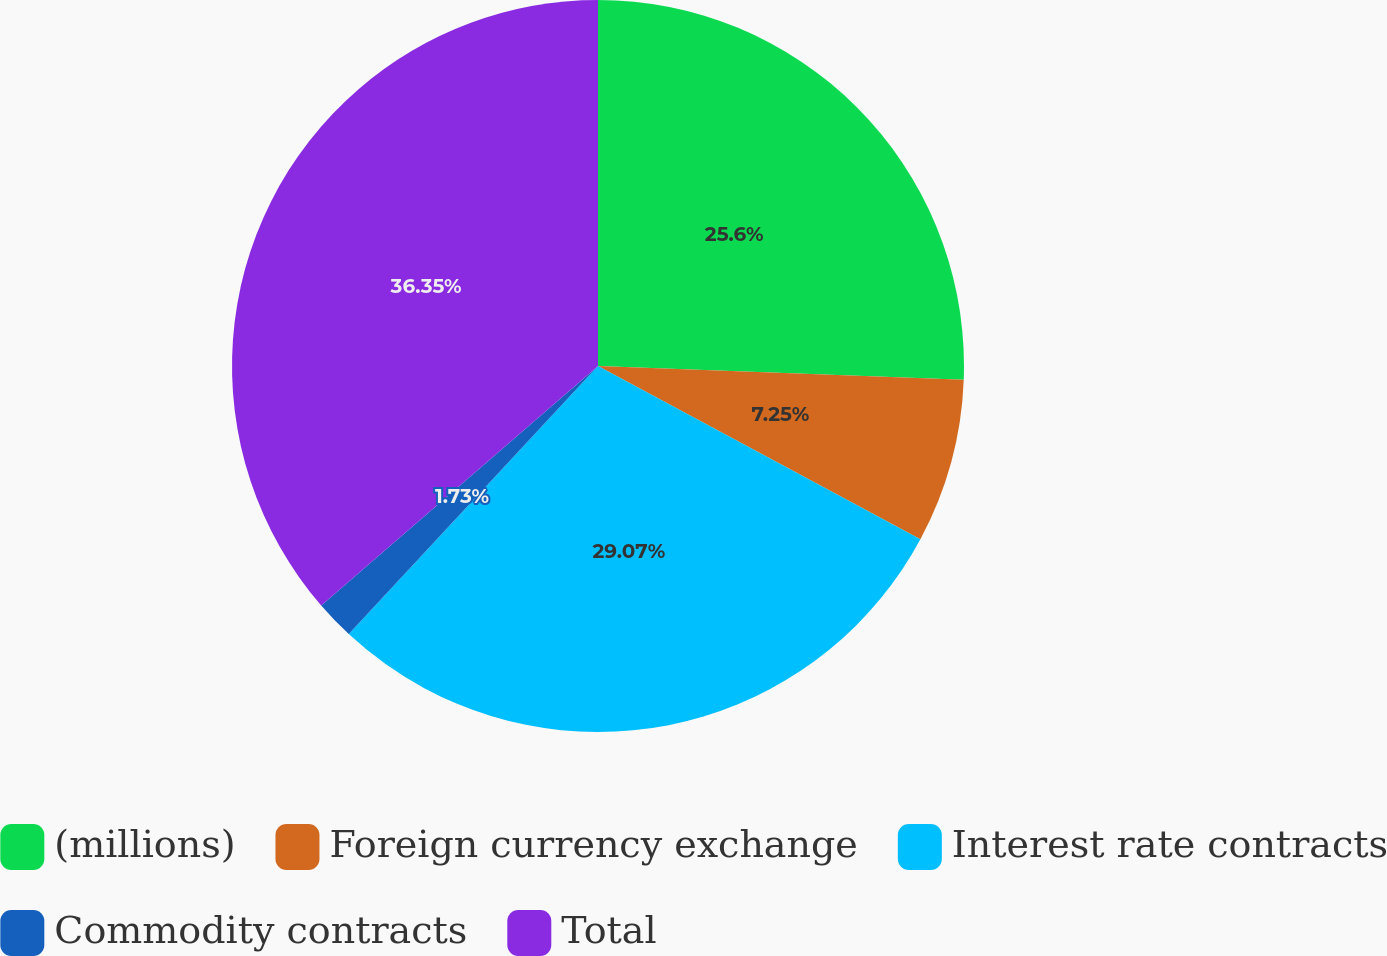Convert chart to OTSL. <chart><loc_0><loc_0><loc_500><loc_500><pie_chart><fcel>(millions)<fcel>Foreign currency exchange<fcel>Interest rate contracts<fcel>Commodity contracts<fcel>Total<nl><fcel>25.6%<fcel>7.25%<fcel>29.07%<fcel>1.73%<fcel>36.35%<nl></chart> 